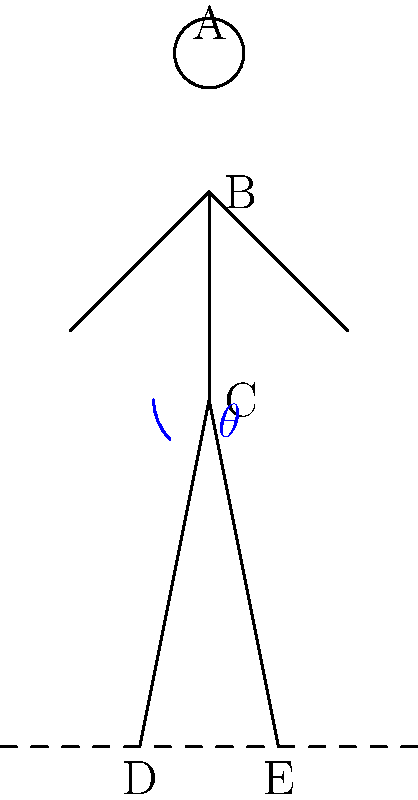In the stick figure diagram representing a runway walk posture, which angle $\theta$ at the hip (point C) is generally considered optimal for a confident and elegant stance?

A) 15°
B) 30°
C) 45°
D) 60° To determine the optimal angle $\theta$ for a runway walk posture, we need to consider the following factors:

1. Balance: The angle should provide a stable base without appearing too wide or narrow.
2. Elegance: The posture should appear graceful and elongated.
3. Confidence: The stance should project strength and poise.

Let's analyze each option:

A) 15°: This angle is too small, resulting in a stance that's too narrow and unstable.
B) 30°: This angle provides a good balance between stability and elegance. It allows for a confident posture without appearing too wide or aggressive.
C) 45°: While this angle offers stability, it can make the stance appear too wide and less elegant for runway walking.
D) 60°: This angle is excessively wide, compromising the model's ability to walk smoothly and elegantly.

In professional modeling and pageantry, a hip angle of approximately 30° is often recommended. This angle allows for:

1. Sufficient stability to maintain balance while walking
2. An elongated silhouette that enhances the appearance of the outfit
3. A confident and poised stance that doesn't appear overly aggressive

Therefore, the optimal angle $\theta$ for a runway walk posture is generally considered to be 30°.
Answer: 30° 